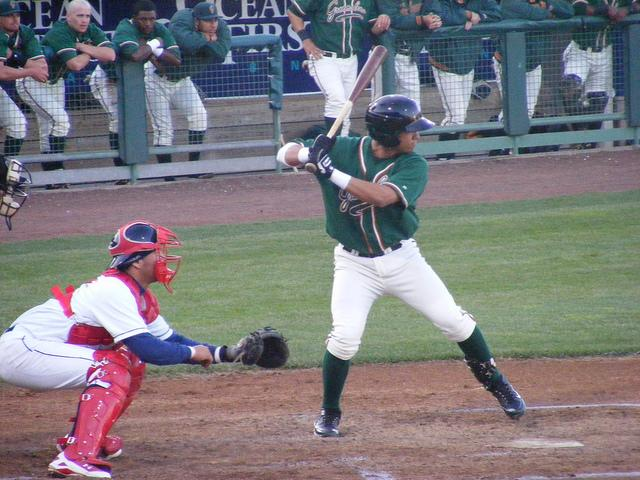What is going to approach the two men in front soon?

Choices:
A) baseball
B) frisbee
C) bullet
D) football baseball 